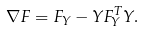<formula> <loc_0><loc_0><loc_500><loc_500>\nabla F = F _ { Y } - Y F _ { Y } ^ { T } Y .</formula> 